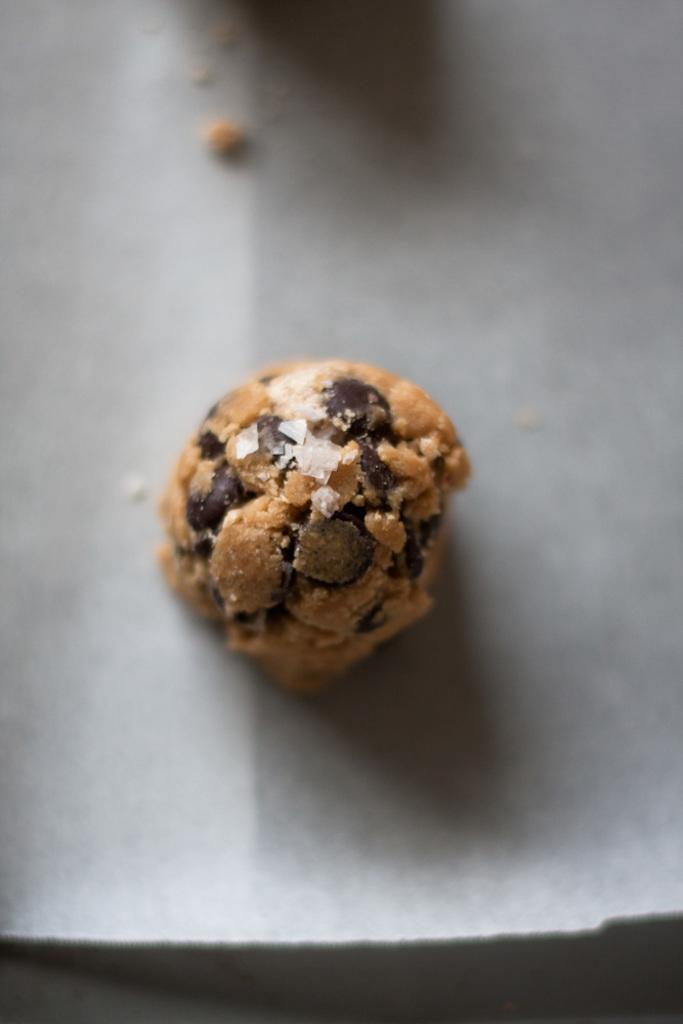What type of food can be seen in the image? The food in the image is in brown color. What is the color of the surface on which the food is placed? The food is placed on a grey color surface. What type of advertisement can be seen in the image? There is no advertisement present in the image; it only features food on a grey surface. 